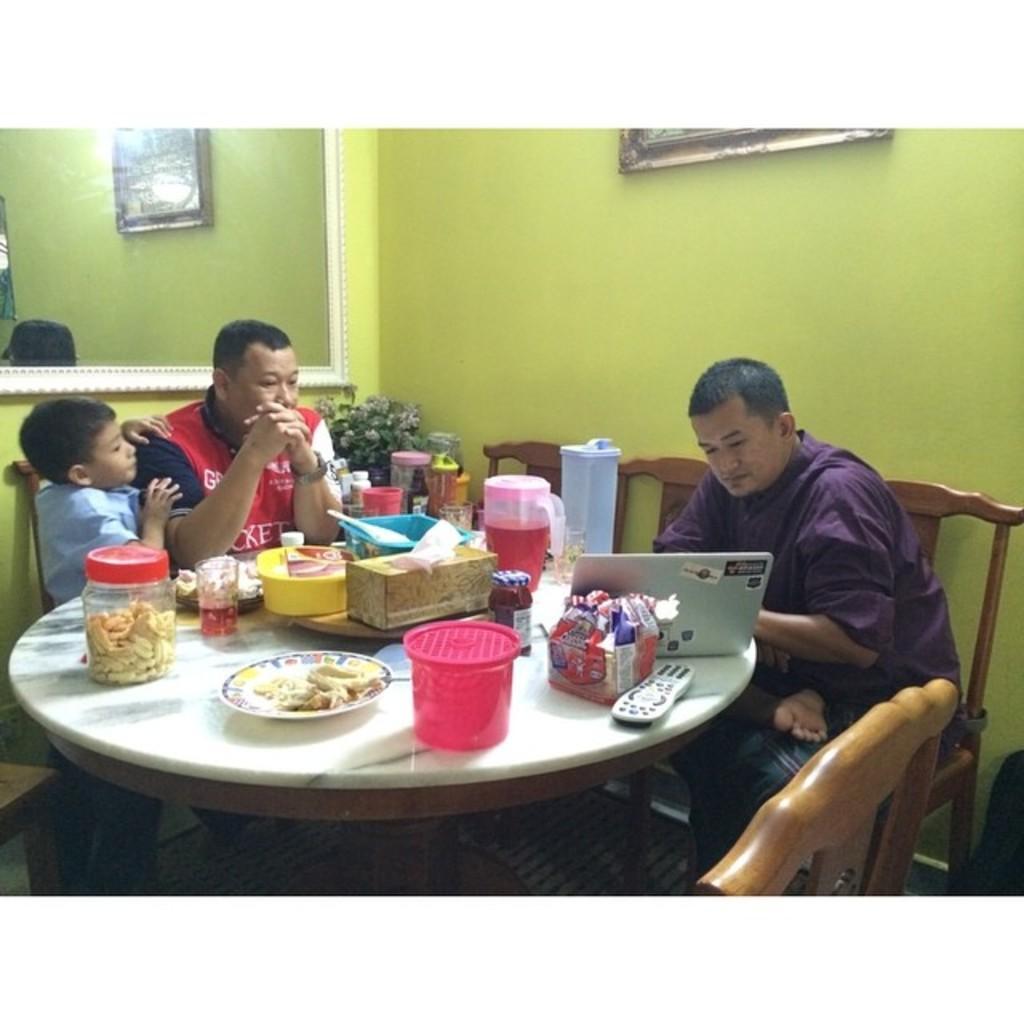How would you summarize this image in a sentence or two? On the background we can see frame over a wall and its reflection in a mirror. We can see three persons sitting on chairs in front of a tablea nd on the table we can see containers and food, a plate of food , remote, glass of drink and a drink in a jar., a house plant. 